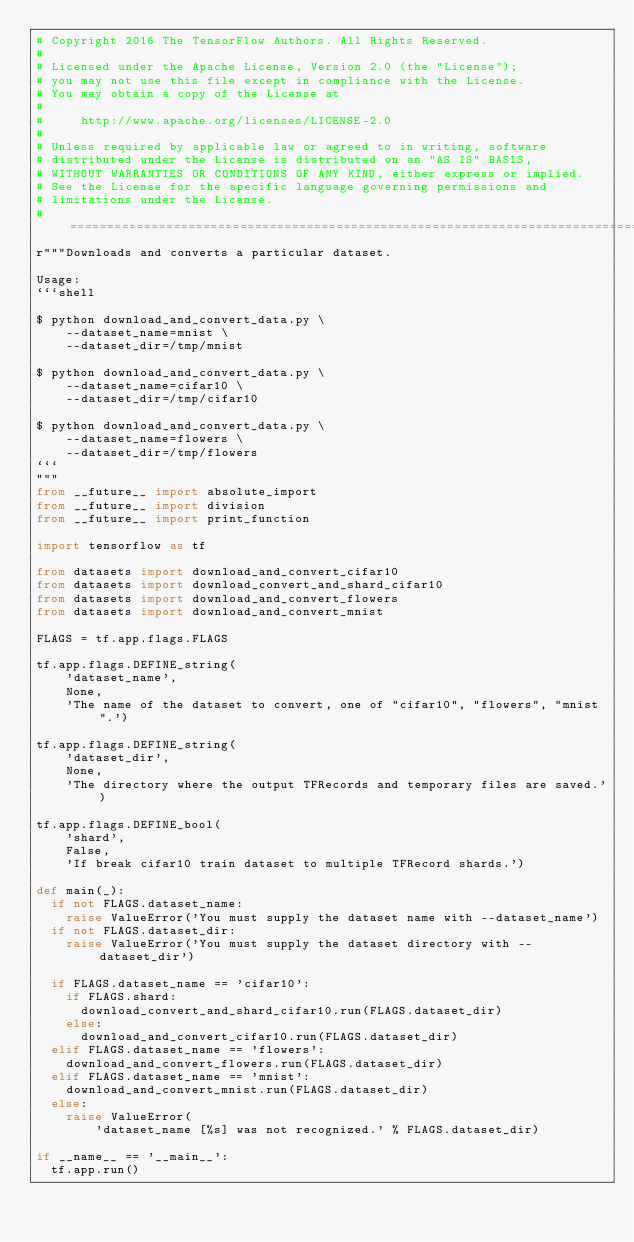Convert code to text. <code><loc_0><loc_0><loc_500><loc_500><_Python_># Copyright 2016 The TensorFlow Authors. All Rights Reserved.
#
# Licensed under the Apache License, Version 2.0 (the "License");
# you may not use this file except in compliance with the License.
# You may obtain a copy of the License at
#
#     http://www.apache.org/licenses/LICENSE-2.0
#
# Unless required by applicable law or agreed to in writing, software
# distributed under the License is distributed on an "AS IS" BASIS,
# WITHOUT WARRANTIES OR CONDITIONS OF ANY KIND, either express or implied.
# See the License for the specific language governing permissions and
# limitations under the License.
# ==============================================================================
r"""Downloads and converts a particular dataset.

Usage:
```shell

$ python download_and_convert_data.py \
    --dataset_name=mnist \
    --dataset_dir=/tmp/mnist

$ python download_and_convert_data.py \
    --dataset_name=cifar10 \
    --dataset_dir=/tmp/cifar10

$ python download_and_convert_data.py \
    --dataset_name=flowers \
    --dataset_dir=/tmp/flowers
```
"""
from __future__ import absolute_import
from __future__ import division
from __future__ import print_function

import tensorflow as tf

from datasets import download_and_convert_cifar10
from datasets import download_convert_and_shard_cifar10
from datasets import download_and_convert_flowers
from datasets import download_and_convert_mnist

FLAGS = tf.app.flags.FLAGS

tf.app.flags.DEFINE_string(
    'dataset_name',
    None,
    'The name of the dataset to convert, one of "cifar10", "flowers", "mnist".')

tf.app.flags.DEFINE_string(
    'dataset_dir',
    None,
    'The directory where the output TFRecords and temporary files are saved.')

tf.app.flags.DEFINE_bool(
    'shard',
    False,
    'If break cifar10 train dataset to multiple TFRecord shards.')

def main(_):
  if not FLAGS.dataset_name:
    raise ValueError('You must supply the dataset name with --dataset_name')
  if not FLAGS.dataset_dir:
    raise ValueError('You must supply the dataset directory with --dataset_dir')

  if FLAGS.dataset_name == 'cifar10':
    if FLAGS.shard:
      download_convert_and_shard_cifar10.run(FLAGS.dataset_dir)
    else:
      download_and_convert_cifar10.run(FLAGS.dataset_dir)
  elif FLAGS.dataset_name == 'flowers':
    download_and_convert_flowers.run(FLAGS.dataset_dir)
  elif FLAGS.dataset_name == 'mnist':
    download_and_convert_mnist.run(FLAGS.dataset_dir)
  else:
    raise ValueError(
        'dataset_name [%s] was not recognized.' % FLAGS.dataset_dir)

if __name__ == '__main__':
  tf.app.run()

</code> 